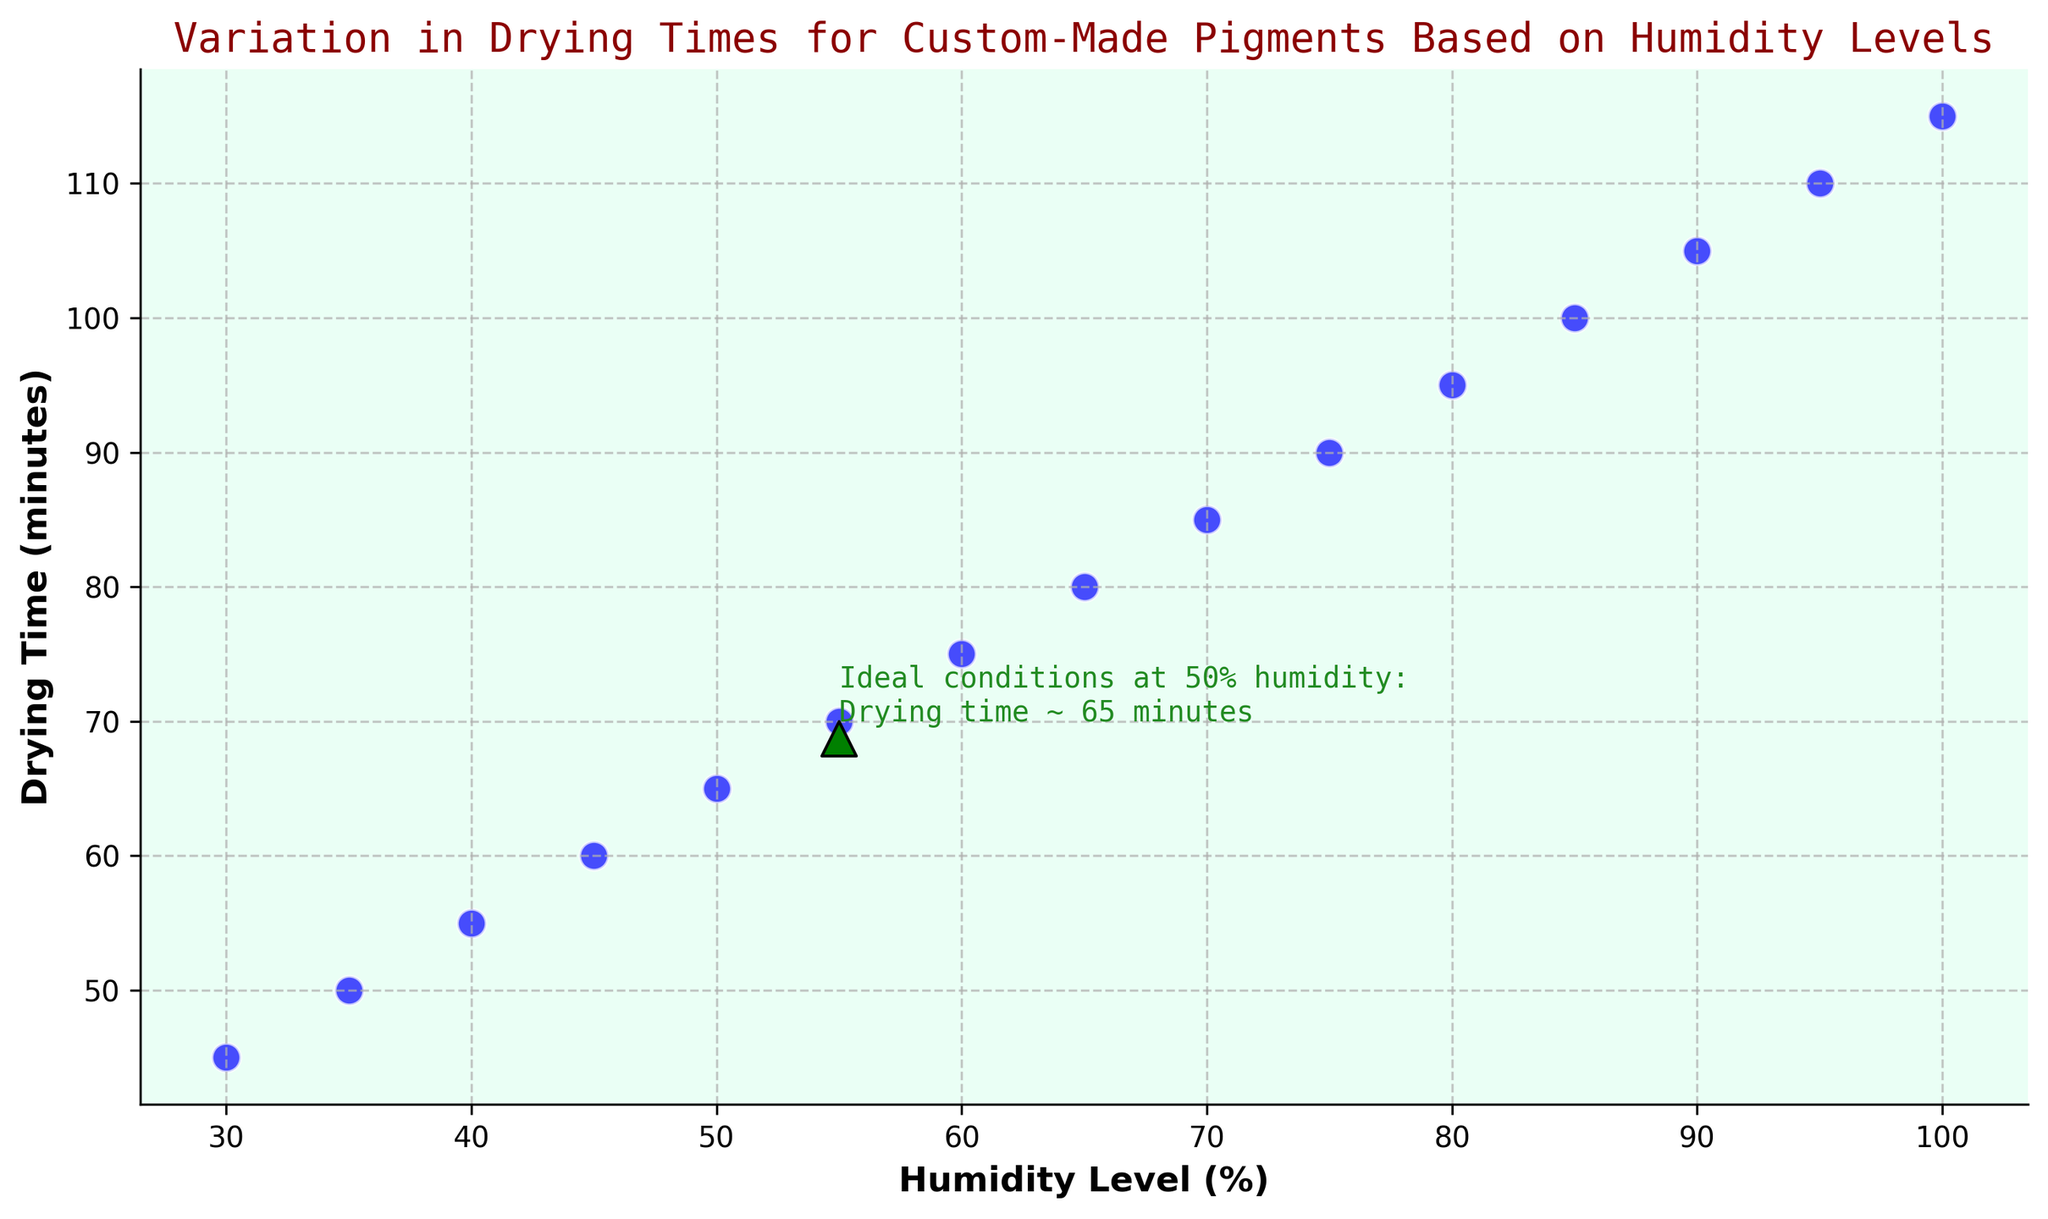What is the drying time when humidity level is 75%? Look at the data point where the humidity level on the x-axis is 75. The corresponding y-axis value gives the drying time.
Answer: 90 minutes What is the difference in drying time between 30% and 70% humidity? Find the drying times for 30% and 70% humidity by locating the corresponding points on the y-axis. Subtract the drying time at 30% humidity from the drying time at 70% humidity.
Answer: 40 minutes At which humidity level does the drying time reach 100 minutes? Identify the data point on the y-axis with the value of 100 minutes, then check its corresponding x-axis value for the humidity level.
Answer: 85% What are the drying times for 35% and 65% humidity? Which one is greater? Locate the drying times corresponding to 35% and 65% humidity levels on the y-axis. Compare these values to determine which is greater.
Answer: 80 minutes (65%) is greater than 50 minutes (35%) By how much does the drying time increase when the humidity level goes from 45% to 95%? Find the drying times for 45% and 95% humidity levels on the y-axis, then calculate the increase by subtracting the drying time at 45% from the drying time at 95%.
Answer: 50 minutes What is the visual style of the text annotation on the plot? Observe the color and font style of the annotated text and any additional features like arrows or boxes.
Answer: Forest green color, monospaced font, with an arrow Which humidity level is noted as having ideal conditions and why? Refer to the text annotation on the plot which mentions the ideal conditions. Identify the humidity level and the reason stated in the annotation.
Answer: 50% humidity, drying time of ~65 minutes How does the drying time vary with increasing humidity levels? Observe the trend of data points as the x-axis (humidity levels) increases. The data points form a clear upward trend, indicating drying time increases.
Answer: Increases What is the average drying time across all humidity levels? Sum up all the drying times and divide by the total number of data points (15). [(45+50+55+60+65+70+75+80+85+90+95+100+105+110+115) / 15]
Answer: 80 minutes 